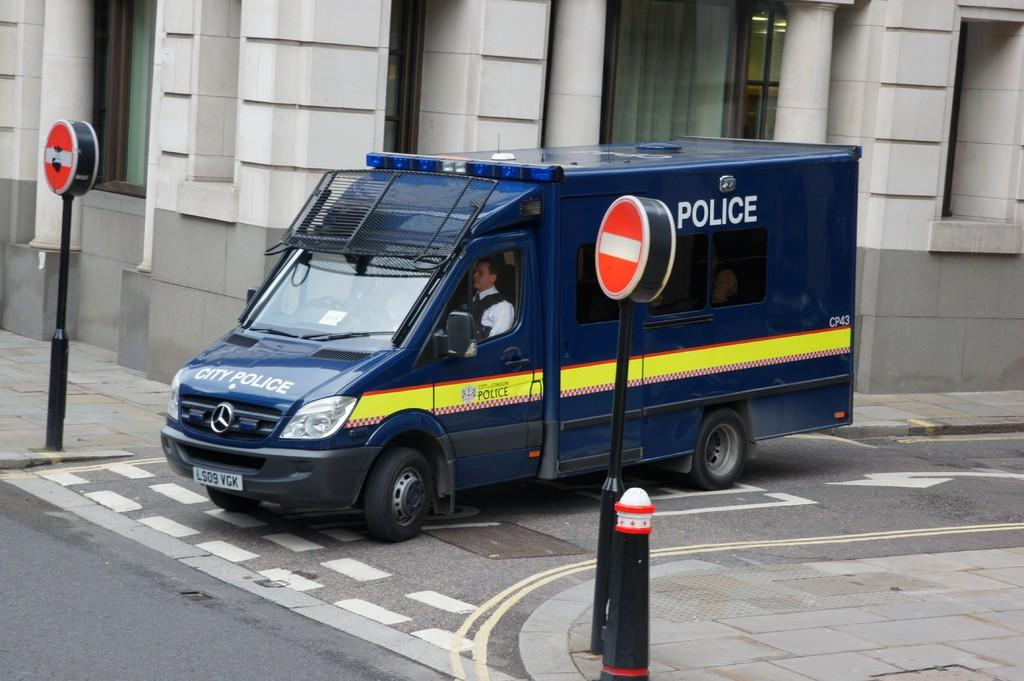Provide a one-sentence caption for the provided image. A large blue Police van sits at the junction of a city street. 